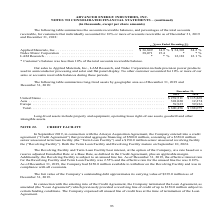According to Advanced Energy's financial document, What was the amount of long-lived assets in United States in 2019? According to the financial document, 239,511 (in thousands). The relevant text states: "United States . $ 239,511 $ 115,869 Asia . 301,020 12,274 Europe . 59,925 59,936 Total . $ 600,456 $ 188,079..." Also, What was the amount of long-lived assets in Europe in 2019? According to the financial document, 59,925 (in thousands). The relevant text states: "239,511 $ 115,869 Asia . 301,020 12,274 Europe . 59,925 59,936 Total . $ 600,456 $ 188,079..." Also, What does Long-lived assets include? Based on the financial document, the answer is property and equipment, operating lease right-of-use assets, goodwill and other intangible assets. Also, can you calculate: What was the change in the amount of long-lived assets between 2018 and 2019 in United States? Based on the calculation: $239,511-$115,869, the result is 123642 (in thousands). This is based on the information: "United States . $ 239,511 $ 115,869 Asia . 301,020 12,274 Europe . 59,925 59,936 Total . $ 600,456 $ 188,079 United States . $ 239,511 $ 115,869 Asia . 301,020 12,274 Europe . 59,925 59,936 Total . $ ..." The key data points involved are: 115,869, 239,511. Also, can you calculate: What is the sum of the highest two long-lived assets in 2018? Based on the calculation: $115,869+59,936, the result is 175805 (in thousands). This is based on the information: "1 $ 115,869 Asia . 301,020 12,274 Europe . 59,925 59,936 Total . $ 600,456 $ 188,079 United States . $ 239,511 $ 115,869 Asia . 301,020 12,274 Europe . 59,925 59,936 Total . $ 600,456 $ 188,079..." The key data points involved are: 115,869, 59,936. Also, can you calculate: What was the percentage change in total long-lived assets between 2018 and 2019? To answer this question, I need to perform calculations using the financial data. The calculation is: ($600,456-$188,079)/$188,079, which equals 219.26 (percentage). This is based on the information: ". 301,020 12,274 Europe . 59,925 59,936 Total . $ 600,456 $ 188,079 12,274 Europe . 59,925 59,936 Total . $ 600,456 $ 188,079..." The key data points involved are: 188,079, 600,456. 